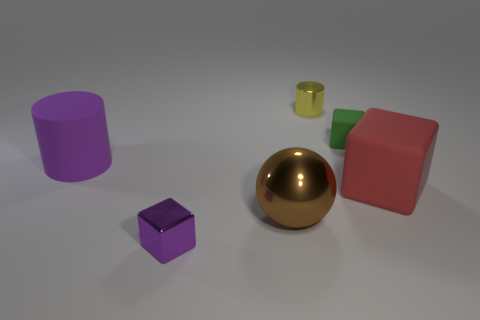Subtract all small rubber blocks. How many blocks are left? 2 Add 2 large purple metallic balls. How many objects exist? 8 Subtract all spheres. How many objects are left? 5 Subtract 2 cylinders. How many cylinders are left? 0 Subtract all green cubes. How many cubes are left? 2 Subtract 0 cyan cylinders. How many objects are left? 6 Subtract all green cubes. Subtract all blue spheres. How many cubes are left? 2 Subtract all blue cylinders. How many red cubes are left? 1 Subtract all purple shiny objects. Subtract all large cyan metal balls. How many objects are left? 5 Add 1 matte cubes. How many matte cubes are left? 3 